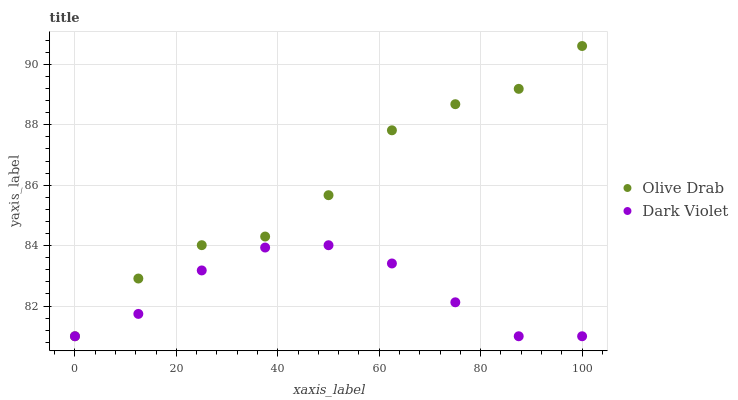Does Dark Violet have the minimum area under the curve?
Answer yes or no. Yes. Does Olive Drab have the maximum area under the curve?
Answer yes or no. Yes. Does Olive Drab have the minimum area under the curve?
Answer yes or no. No. Is Dark Violet the smoothest?
Answer yes or no. Yes. Is Olive Drab the roughest?
Answer yes or no. Yes. Is Olive Drab the smoothest?
Answer yes or no. No. Does Dark Violet have the lowest value?
Answer yes or no. Yes. Does Olive Drab have the highest value?
Answer yes or no. Yes. Does Olive Drab intersect Dark Violet?
Answer yes or no. Yes. Is Olive Drab less than Dark Violet?
Answer yes or no. No. Is Olive Drab greater than Dark Violet?
Answer yes or no. No. 